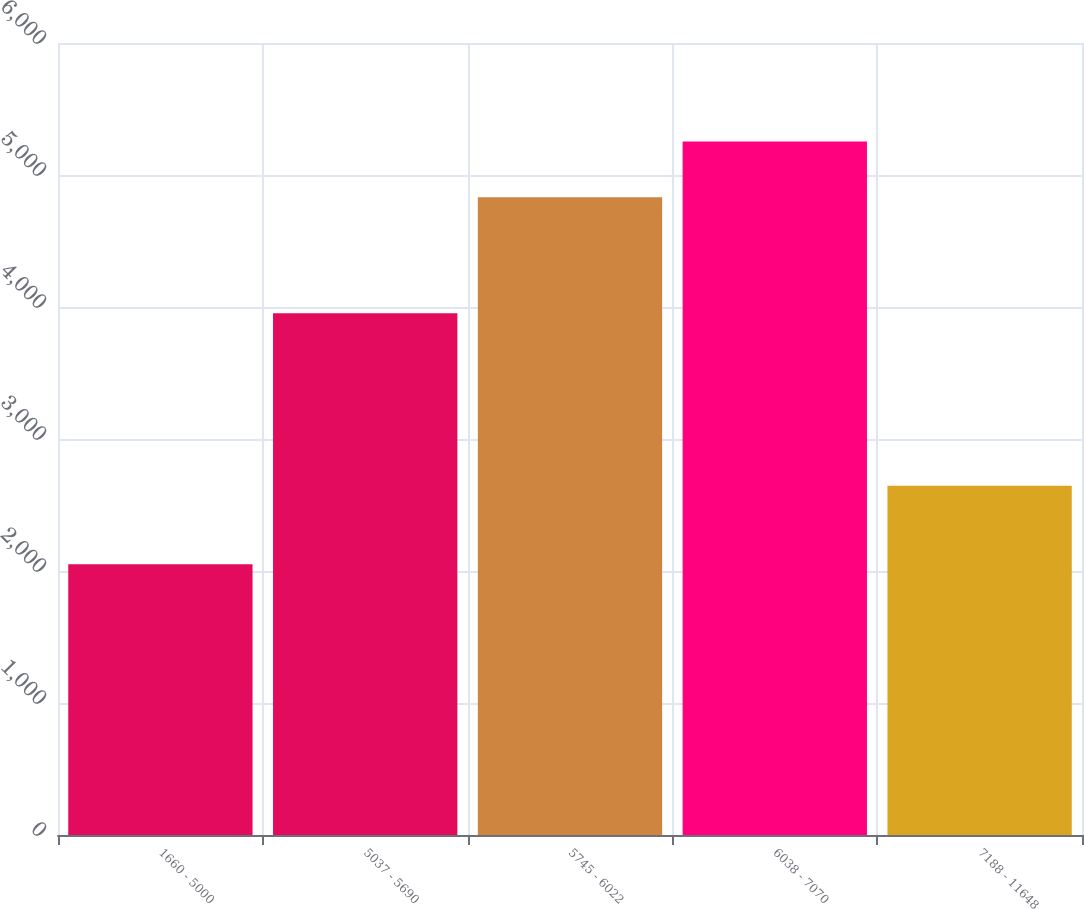Convert chart. <chart><loc_0><loc_0><loc_500><loc_500><bar_chart><fcel>1660 - 5000<fcel>5037 - 5690<fcel>5745 - 6022<fcel>6038 - 7070<fcel>7188 - 11648<nl><fcel>2052<fcel>3953<fcel>4831<fcel>5253<fcel>2645<nl></chart> 